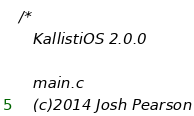<code> <loc_0><loc_0><loc_500><loc_500><_C_>/* 
   KallistiOS 2.0.0

   main.c
   (c)2014 Josh Pearson</code> 